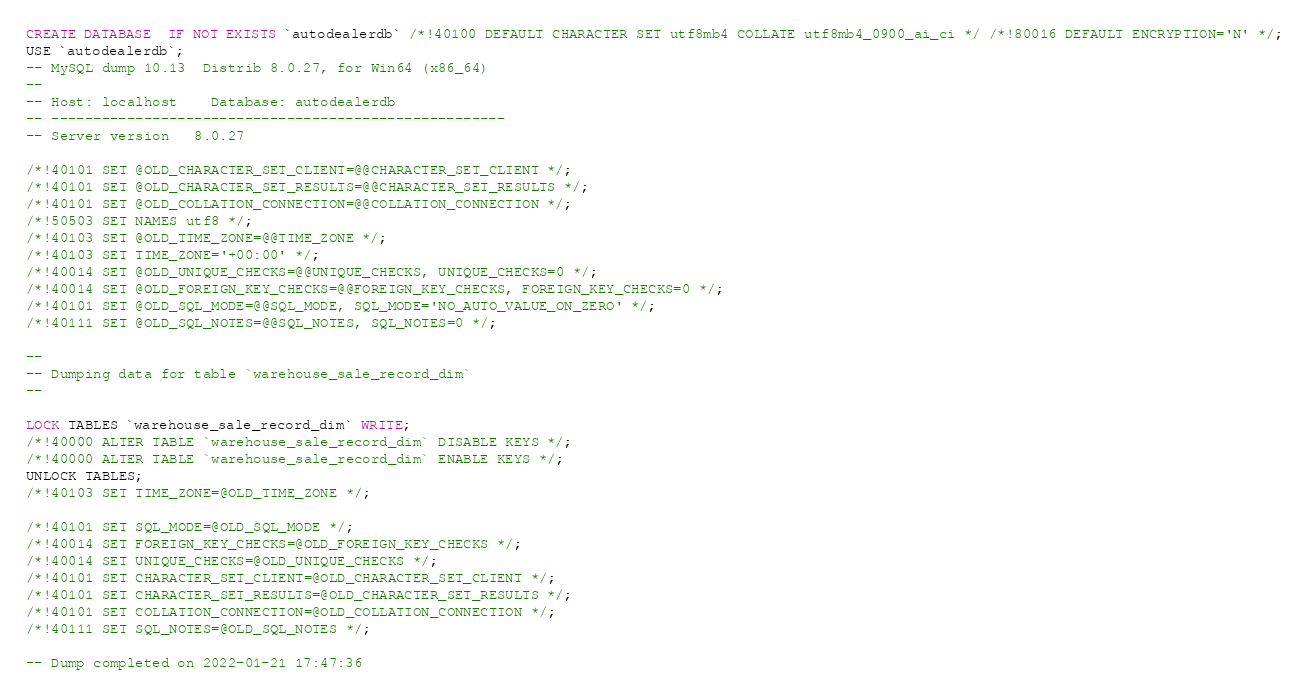<code> <loc_0><loc_0><loc_500><loc_500><_SQL_>CREATE DATABASE  IF NOT EXISTS `autodealerdb` /*!40100 DEFAULT CHARACTER SET utf8mb4 COLLATE utf8mb4_0900_ai_ci */ /*!80016 DEFAULT ENCRYPTION='N' */;
USE `autodealerdb`;
-- MySQL dump 10.13  Distrib 8.0.27, for Win64 (x86_64)
--
-- Host: localhost    Database: autodealerdb
-- ------------------------------------------------------
-- Server version	8.0.27

/*!40101 SET @OLD_CHARACTER_SET_CLIENT=@@CHARACTER_SET_CLIENT */;
/*!40101 SET @OLD_CHARACTER_SET_RESULTS=@@CHARACTER_SET_RESULTS */;
/*!40101 SET @OLD_COLLATION_CONNECTION=@@COLLATION_CONNECTION */;
/*!50503 SET NAMES utf8 */;
/*!40103 SET @OLD_TIME_ZONE=@@TIME_ZONE */;
/*!40103 SET TIME_ZONE='+00:00' */;
/*!40014 SET @OLD_UNIQUE_CHECKS=@@UNIQUE_CHECKS, UNIQUE_CHECKS=0 */;
/*!40014 SET @OLD_FOREIGN_KEY_CHECKS=@@FOREIGN_KEY_CHECKS, FOREIGN_KEY_CHECKS=0 */;
/*!40101 SET @OLD_SQL_MODE=@@SQL_MODE, SQL_MODE='NO_AUTO_VALUE_ON_ZERO' */;
/*!40111 SET @OLD_SQL_NOTES=@@SQL_NOTES, SQL_NOTES=0 */;

--
-- Dumping data for table `warehouse_sale_record_dim`
--

LOCK TABLES `warehouse_sale_record_dim` WRITE;
/*!40000 ALTER TABLE `warehouse_sale_record_dim` DISABLE KEYS */;
/*!40000 ALTER TABLE `warehouse_sale_record_dim` ENABLE KEYS */;
UNLOCK TABLES;
/*!40103 SET TIME_ZONE=@OLD_TIME_ZONE */;

/*!40101 SET SQL_MODE=@OLD_SQL_MODE */;
/*!40014 SET FOREIGN_KEY_CHECKS=@OLD_FOREIGN_KEY_CHECKS */;
/*!40014 SET UNIQUE_CHECKS=@OLD_UNIQUE_CHECKS */;
/*!40101 SET CHARACTER_SET_CLIENT=@OLD_CHARACTER_SET_CLIENT */;
/*!40101 SET CHARACTER_SET_RESULTS=@OLD_CHARACTER_SET_RESULTS */;
/*!40101 SET COLLATION_CONNECTION=@OLD_COLLATION_CONNECTION */;
/*!40111 SET SQL_NOTES=@OLD_SQL_NOTES */;

-- Dump completed on 2022-01-21 17:47:36
</code> 